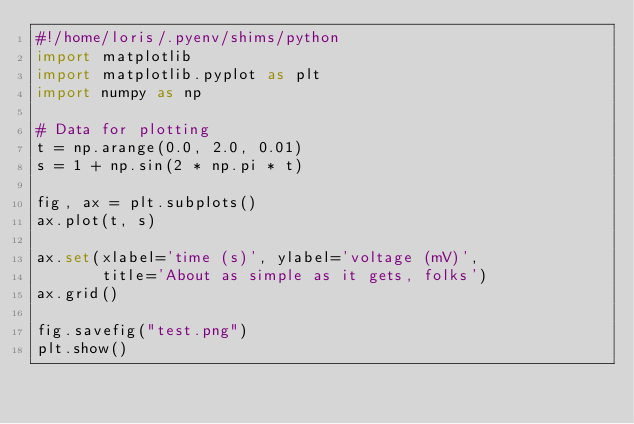Convert code to text. <code><loc_0><loc_0><loc_500><loc_500><_Python_>#!/home/loris/.pyenv/shims/python
import matplotlib
import matplotlib.pyplot as plt
import numpy as np

# Data for plotting
t = np.arange(0.0, 2.0, 0.01)
s = 1 + np.sin(2 * np.pi * t)

fig, ax = plt.subplots()
ax.plot(t, s)

ax.set(xlabel='time (s)', ylabel='voltage (mV)',
       title='About as simple as it gets, folks')
ax.grid()

fig.savefig("test.png")
plt.show()
</code> 